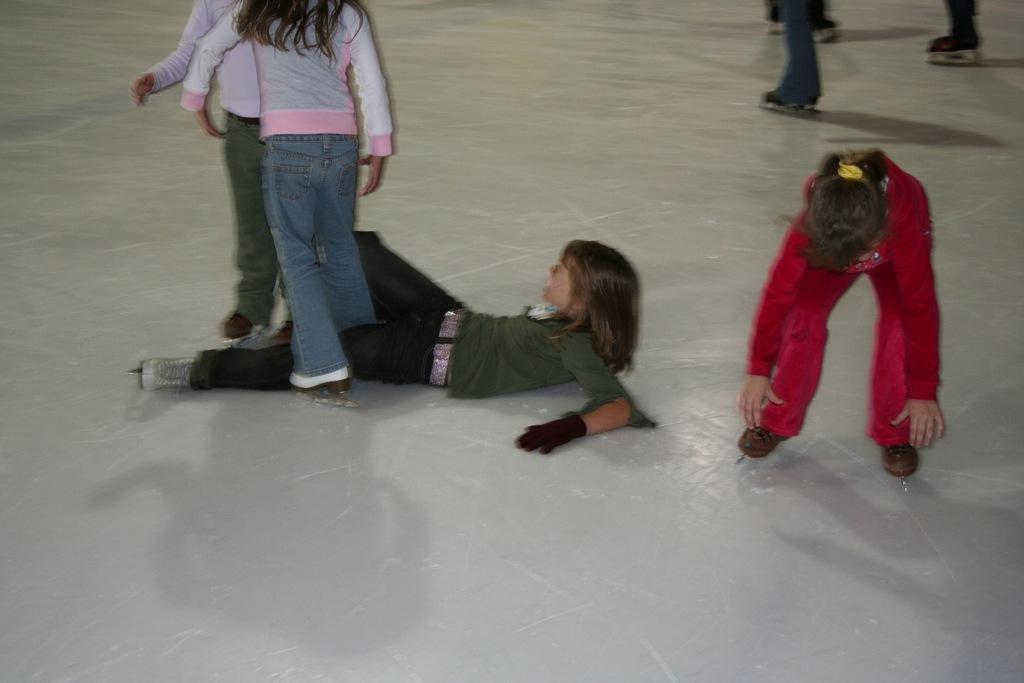Please provide a concise description of this image. In this image we can see few people. A person is lying on the floor. 